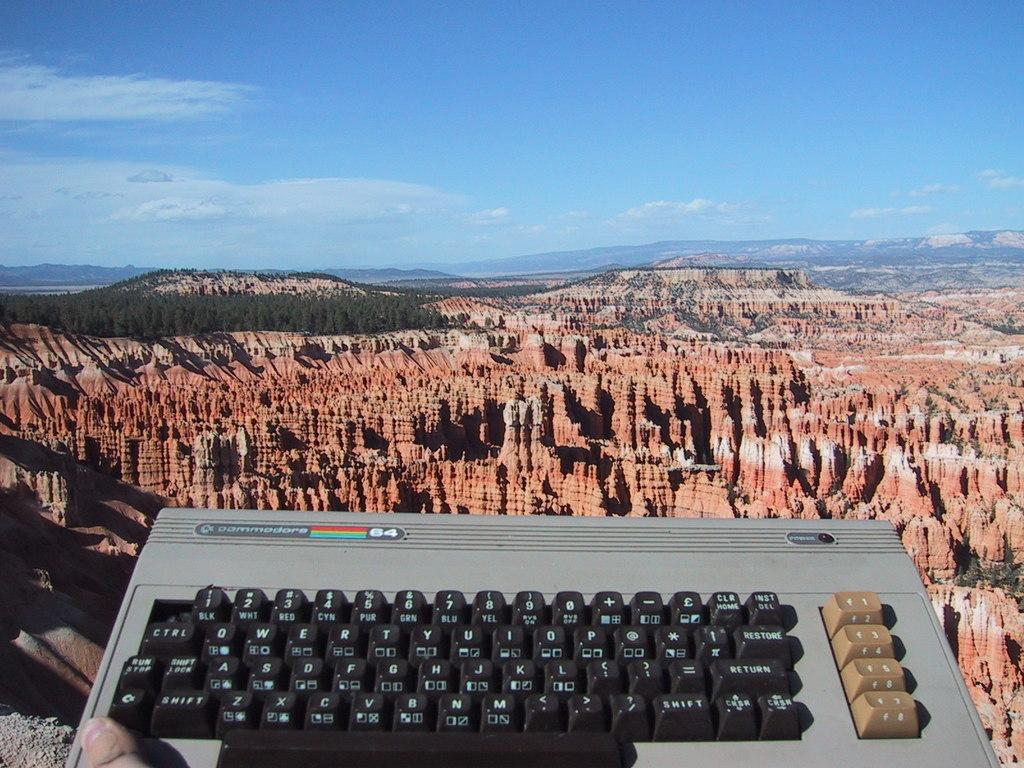<image>
Write a terse but informative summary of the picture. a keyboard next to a canyon with the word shift on it 